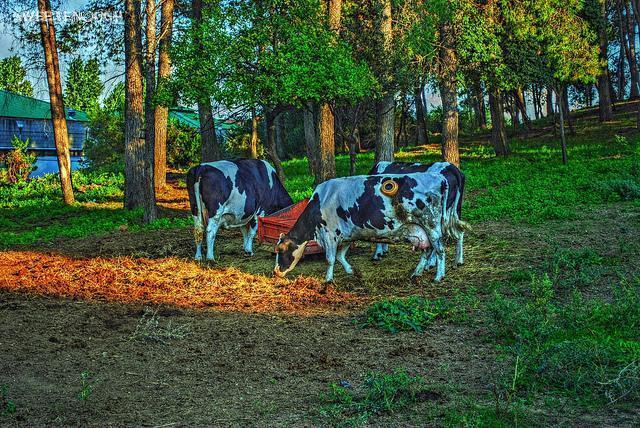How many cows are in the field?
Give a very brief answer. 3. How many cows are in the photo?
Give a very brief answer. 3. 